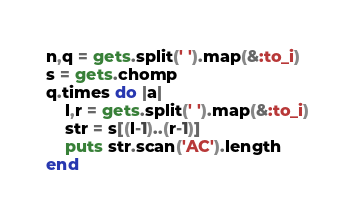<code> <loc_0><loc_0><loc_500><loc_500><_Ruby_>n,q = gets.split(' ').map(&:to_i)
s = gets.chomp
q.times do |a|
    l,r = gets.split(' ').map(&:to_i)
    str = s[(l-1)..(r-1)]
    puts str.scan('AC').length
end</code> 